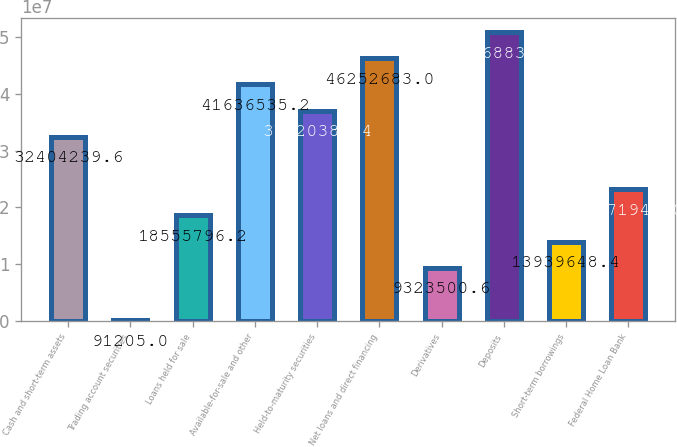Convert chart. <chart><loc_0><loc_0><loc_500><loc_500><bar_chart><fcel>Cash and short-term assets<fcel>Trading account securities<fcel>Loans held for sale<fcel>Available-for-sale and other<fcel>Held-to-maturity securities<fcel>Net loans and direct financing<fcel>Derivatives<fcel>Deposits<fcel>Short-term borrowings<fcel>Federal Home Loan Bank<nl><fcel>3.24042e+07<fcel>91205<fcel>1.85558e+07<fcel>4.16365e+07<fcel>3.70204e+07<fcel>4.62527e+07<fcel>9.3235e+06<fcel>5.08688e+07<fcel>1.39396e+07<fcel>2.31719e+07<nl></chart> 